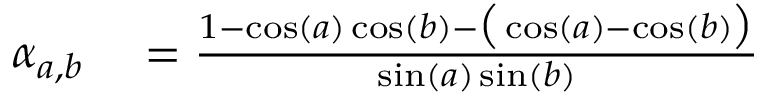Convert formula to latex. <formula><loc_0><loc_0><loc_500><loc_500>\begin{array} { r l } { \alpha _ { a , b } } & = \frac { 1 - \cos ( a ) \cos ( b ) - \left ( \cos ( a ) - \cos ( b ) \right ) } { \sin ( a ) \sin ( b ) } } \end{array}</formula> 